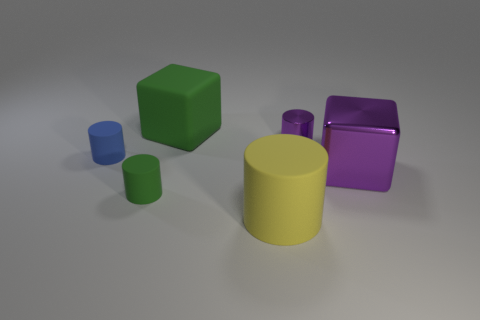Add 3 blue matte objects. How many objects exist? 9 Subtract all red cylinders. Subtract all gray blocks. How many cylinders are left? 4 Subtract all cylinders. How many objects are left? 2 Subtract all tiny cyan shiny cylinders. Subtract all large yellow matte things. How many objects are left? 5 Add 5 blue matte cylinders. How many blue matte cylinders are left? 6 Add 2 big purple shiny cubes. How many big purple shiny cubes exist? 3 Subtract 0 brown cubes. How many objects are left? 6 